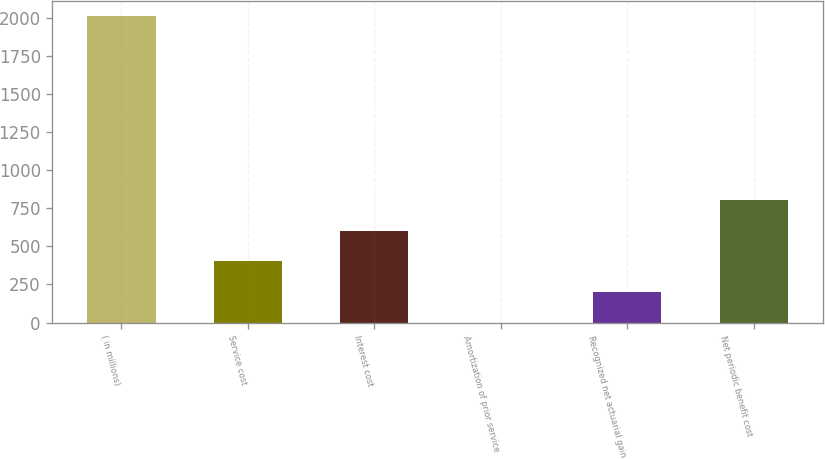Convert chart. <chart><loc_0><loc_0><loc_500><loc_500><bar_chart><fcel>( in millions)<fcel>Service cost<fcel>Interest cost<fcel>Amortization of prior service<fcel>Recognized net actuarial gain<fcel>Net periodic benefit cost<nl><fcel>2010<fcel>402.16<fcel>603.14<fcel>0.2<fcel>201.18<fcel>804.12<nl></chart> 